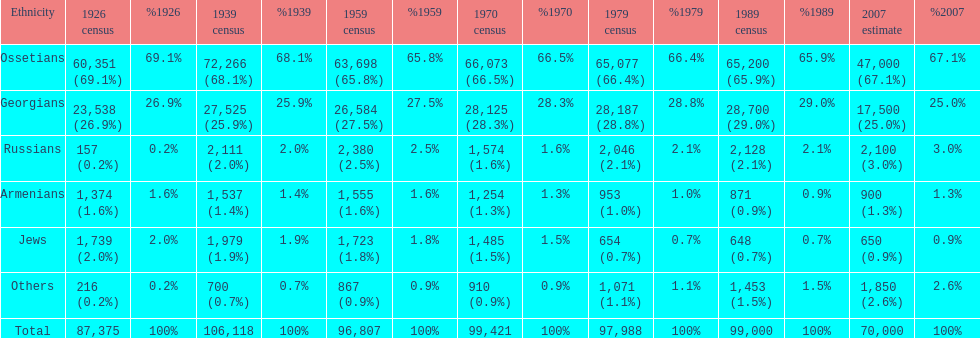Which population had the most people in 1926? Ossetians. 